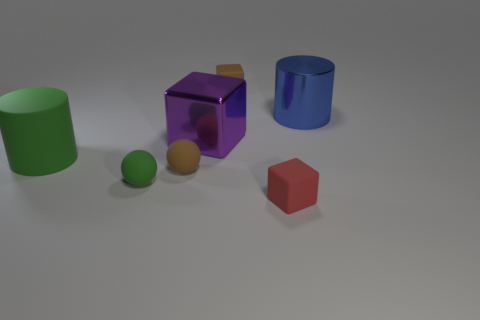Add 3 big gray metal cylinders. How many objects exist? 10 Subtract all spheres. How many objects are left? 5 Add 6 brown rubber things. How many brown rubber things are left? 8 Add 7 large blue matte balls. How many large blue matte balls exist? 7 Subtract 1 brown balls. How many objects are left? 6 Subtract all small brown spheres. Subtract all cylinders. How many objects are left? 4 